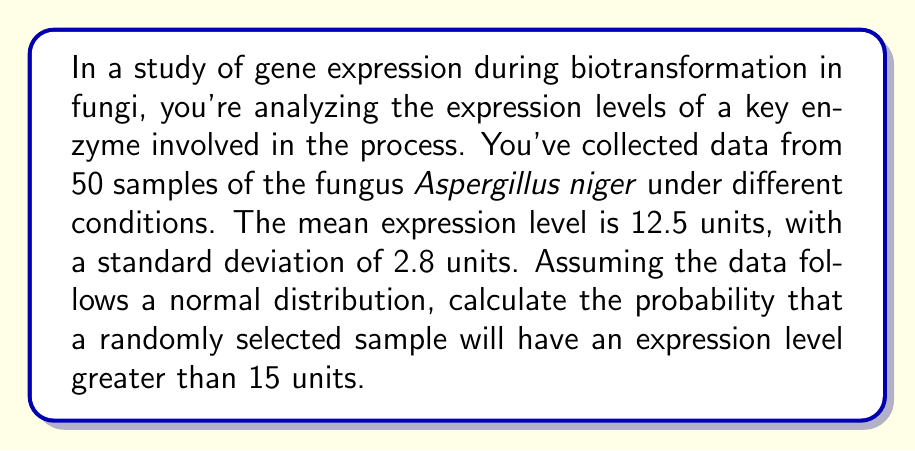What is the answer to this math problem? To solve this problem, we'll use the standard normal distribution (z-score) approach:

1. First, we need to calculate the z-score for the expression level of 15 units:

   $$ z = \frac{x - \mu}{\sigma} $$

   Where:
   $x$ is the value of interest (15 units)
   $\mu$ is the mean (12.5 units)
   $\sigma$ is the standard deviation (2.8 units)

2. Plugging in the values:

   $$ z = \frac{15 - 12.5}{2.8} = \frac{2.5}{2.8} \approx 0.8929 $$

3. Now, we need to find the probability of a z-score greater than 0.8929. This is equivalent to finding the area under the standard normal curve to the right of z = 0.8929.

4. Using a standard normal distribution table or a statistical calculator, we can find that:

   $P(Z > 0.8929) \approx 0.1859$

5. Therefore, the probability of a randomly selected sample having an expression level greater than 15 units is approximately 0.1859 or 18.59%.

This result indicates that about 18.59% of the Aspergillus niger samples are expected to have an expression level of the key enzyme greater than 15 units during the biotransformation process.
Answer: The probability that a randomly selected sample will have an expression level greater than 15 units is approximately 0.1859 or 18.59%. 